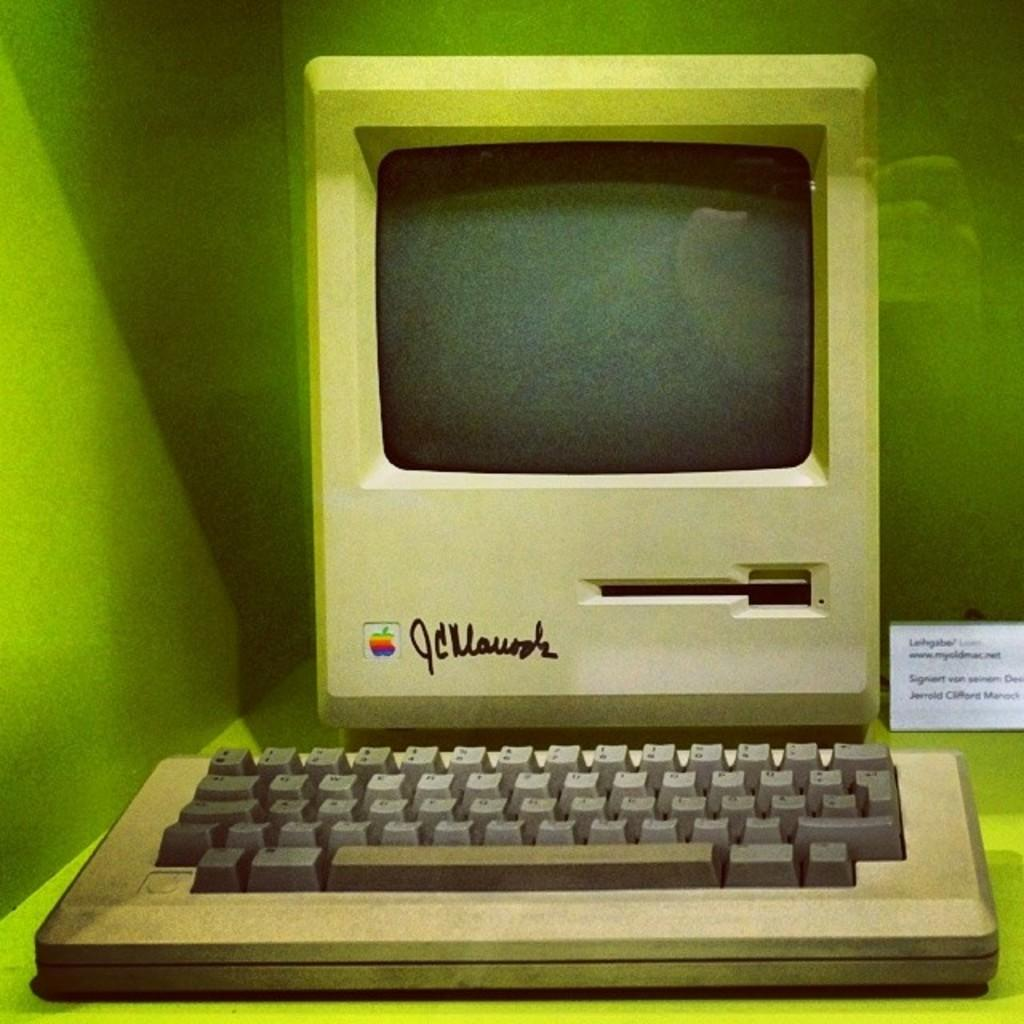<image>
Offer a succinct explanation of the picture presented. Old computer that has the initals of J and C on it. 